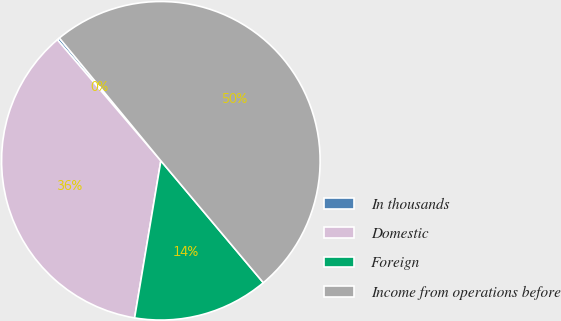Convert chart. <chart><loc_0><loc_0><loc_500><loc_500><pie_chart><fcel>In thousands<fcel>Domestic<fcel>Foreign<fcel>Income from operations before<nl><fcel>0.27%<fcel>36.11%<fcel>13.76%<fcel>49.87%<nl></chart> 